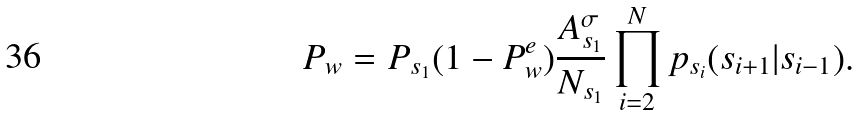<formula> <loc_0><loc_0><loc_500><loc_500>P _ { w } = P _ { s _ { 1 } } ( 1 - P _ { w } ^ { e } ) \frac { A _ { s _ { 1 } } ^ { \sigma } } { { N _ { s _ { 1 } } } } \prod _ { i = 2 } ^ { N } p _ { s _ { i } } ( s _ { i + 1 } | s _ { i - 1 } ) .</formula> 